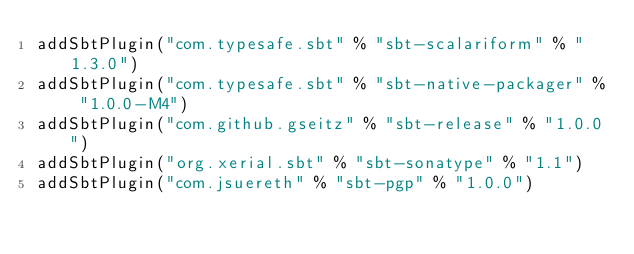Convert code to text. <code><loc_0><loc_0><loc_500><loc_500><_Scala_>addSbtPlugin("com.typesafe.sbt" % "sbt-scalariform" % "1.3.0")
addSbtPlugin("com.typesafe.sbt" % "sbt-native-packager" % "1.0.0-M4")
addSbtPlugin("com.github.gseitz" % "sbt-release" % "1.0.0")
addSbtPlugin("org.xerial.sbt" % "sbt-sonatype" % "1.1")
addSbtPlugin("com.jsuereth" % "sbt-pgp" % "1.0.0")
</code> 